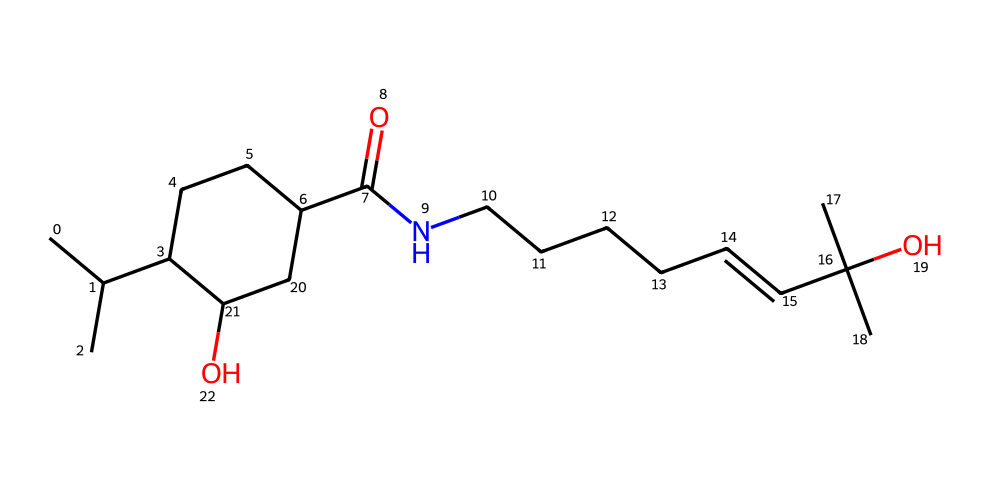What is the total number of carbon atoms in the chemical structure? By analyzing the SMILES representation, we identify each carbon ("C") atom in the given structure. Counting them shows there are 19 carbon atoms present.
Answer: 19 How many hydroxyl (-OH) groups are present in the structure? The presence of hydroxyl groups can be determined by locating the "O" atoms that are directly attached to a carbon and have a hydrogen atom. In this structure, there are two such groups.
Answer: 2 What functional group characterizes this chemical as a phenol? The defining trait of phenols is the presence of a hydroxyl group (-OH) attached to an aromatic ring. In the SMILES, the aromatic structure can be traced with -OH indicating phenolic characteristics.
Answer: hydroxyl group What is the relationship between the number of rings and the number of double bonds in this structure? The compound contains one cyclohexane ring (not aromatic) and several aliphatic double bonds. There are no double bonds within the ring; thus, we compare the overall content. There is 1 ring and 1 identified double bond present.
Answer: 1 ring, 1 double bond Which portion of the molecule indicates that it may have a spicy flavor? The presence of alkaloids, including specific functional groups related to hotness, emerges from the nitrogen arrangement in connection with the hydrocarbon framework. The amide group here is likely to contribute to the heat sensation found in spicy foods.
Answer: amide group 